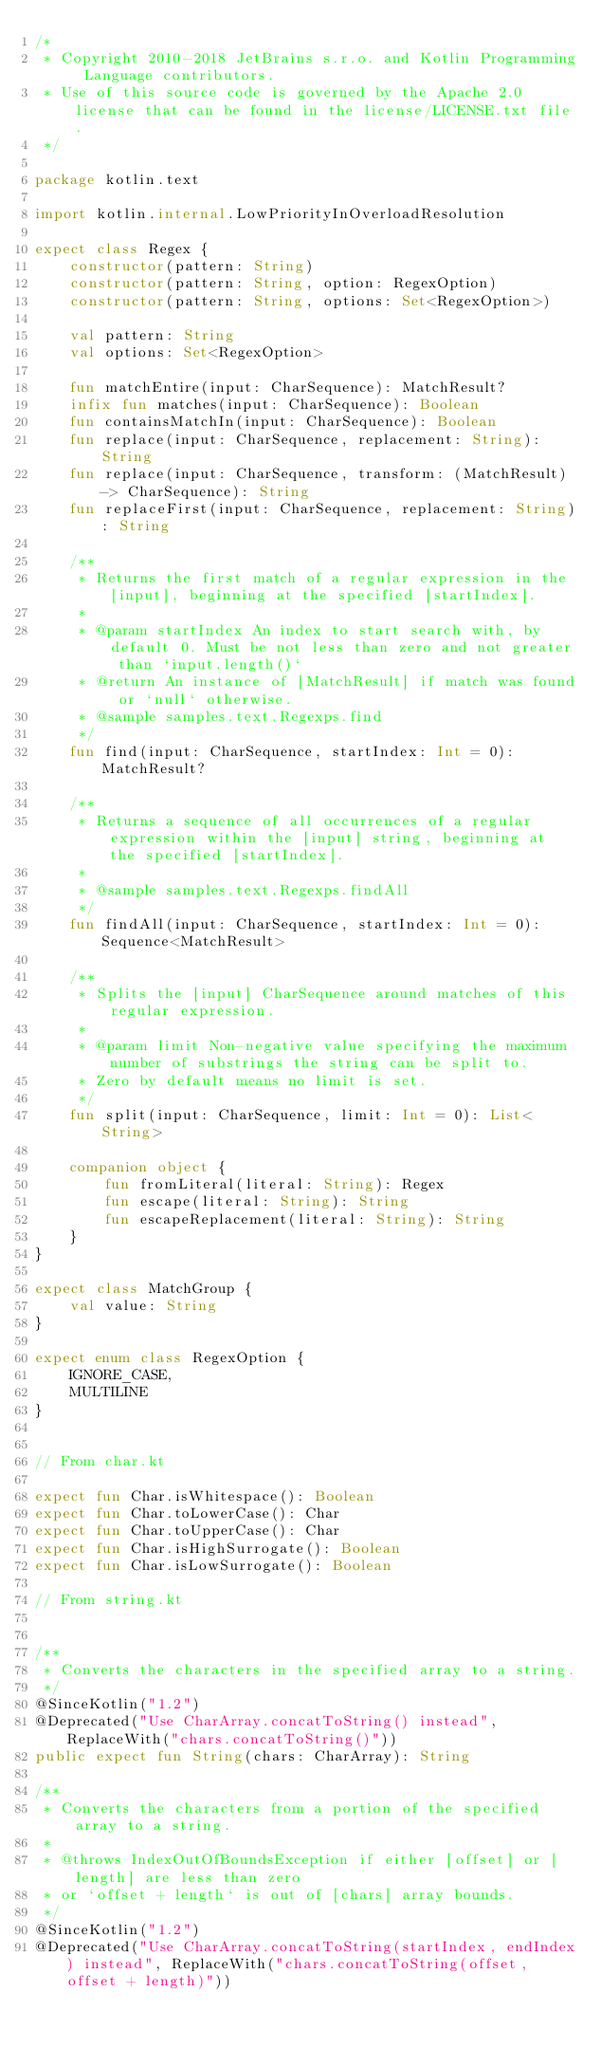Convert code to text. <code><loc_0><loc_0><loc_500><loc_500><_Kotlin_>/*
 * Copyright 2010-2018 JetBrains s.r.o. and Kotlin Programming Language contributors.
 * Use of this source code is governed by the Apache 2.0 license that can be found in the license/LICENSE.txt file.
 */

package kotlin.text

import kotlin.internal.LowPriorityInOverloadResolution

expect class Regex {
    constructor(pattern: String)
    constructor(pattern: String, option: RegexOption)
    constructor(pattern: String, options: Set<RegexOption>)

    val pattern: String
    val options: Set<RegexOption>

    fun matchEntire(input: CharSequence): MatchResult?
    infix fun matches(input: CharSequence): Boolean
    fun containsMatchIn(input: CharSequence): Boolean
    fun replace(input: CharSequence, replacement: String): String
    fun replace(input: CharSequence, transform: (MatchResult) -> CharSequence): String
    fun replaceFirst(input: CharSequence, replacement: String): String

    /**
     * Returns the first match of a regular expression in the [input], beginning at the specified [startIndex].
     *
     * @param startIndex An index to start search with, by default 0. Must be not less than zero and not greater than `input.length()`
     * @return An instance of [MatchResult] if match was found or `null` otherwise.
     * @sample samples.text.Regexps.find
     */
    fun find(input: CharSequence, startIndex: Int = 0): MatchResult?

    /**
     * Returns a sequence of all occurrences of a regular expression within the [input] string, beginning at the specified [startIndex].
     *
     * @sample samples.text.Regexps.findAll
     */
    fun findAll(input: CharSequence, startIndex: Int = 0): Sequence<MatchResult>

    /**
     * Splits the [input] CharSequence around matches of this regular expression.
     *
     * @param limit Non-negative value specifying the maximum number of substrings the string can be split to.
     * Zero by default means no limit is set.
     */
    fun split(input: CharSequence, limit: Int = 0): List<String>

    companion object {
        fun fromLiteral(literal: String): Regex
        fun escape(literal: String): String
        fun escapeReplacement(literal: String): String
    }
}

expect class MatchGroup {
    val value: String
}

expect enum class RegexOption {
    IGNORE_CASE,
    MULTILINE
}


// From char.kt

expect fun Char.isWhitespace(): Boolean
expect fun Char.toLowerCase(): Char
expect fun Char.toUpperCase(): Char
expect fun Char.isHighSurrogate(): Boolean
expect fun Char.isLowSurrogate(): Boolean

// From string.kt


/**
 * Converts the characters in the specified array to a string.
 */
@SinceKotlin("1.2")
@Deprecated("Use CharArray.concatToString() instead", ReplaceWith("chars.concatToString()"))
public expect fun String(chars: CharArray): String

/**
 * Converts the characters from a portion of the specified array to a string.
 *
 * @throws IndexOutOfBoundsException if either [offset] or [length] are less than zero
 * or `offset + length` is out of [chars] array bounds.
 */
@SinceKotlin("1.2")
@Deprecated("Use CharArray.concatToString(startIndex, endIndex) instead", ReplaceWith("chars.concatToString(offset, offset + length)"))</code> 